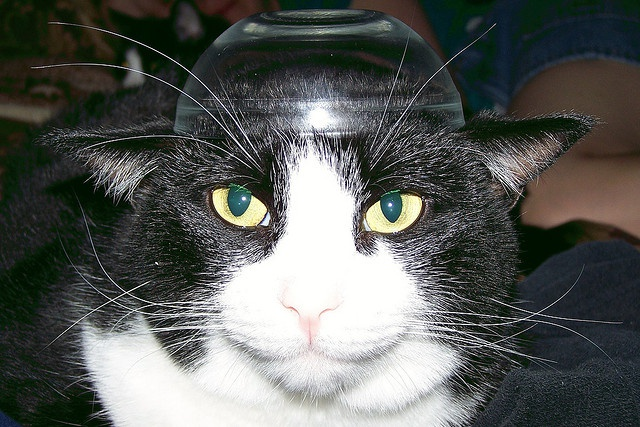Describe the objects in this image and their specific colors. I can see cat in black, white, gray, and darkgray tones and bowl in black, gray, darkgray, and lightgray tones in this image. 